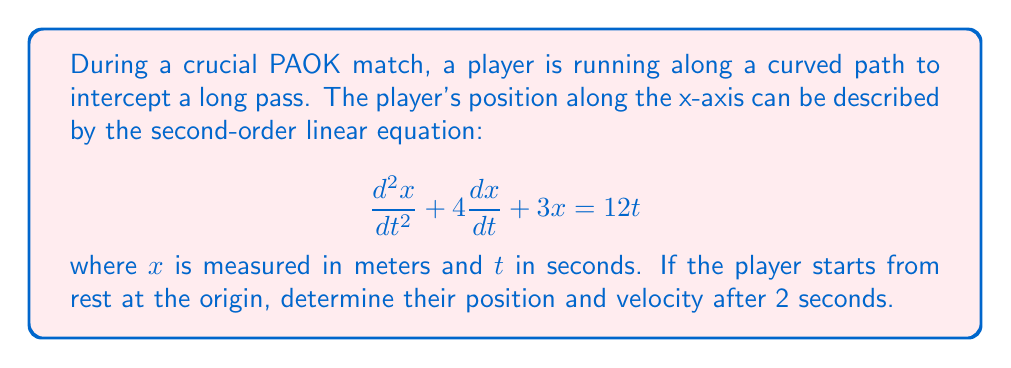Show me your answer to this math problem. To solve this problem, we need to find the general solution to the given second-order linear equation and then apply the initial conditions.

1) The general solution of the homogeneous equation $\frac{d^2x}{dt^2} + 4\frac{dx}{dt} + 3x = 0$ is:

   $x_h = c_1e^{-t} + c_2e^{-3t}$

2) A particular solution for the non-homogeneous equation is:

   $x_p = At + B$

   Substituting this into the original equation:
   $A + 4(A) + 3(At + B) = 12t$
   $A + 4A + 3At + 3B = 12t$
   
   Equating coefficients:
   $3A = 12$, so $A = 4$
   $5A + 3B = 0$, so $B = -\frac{20}{3}$

   Thus, $x_p = 4t - \frac{20}{3}$

3) The general solution is:

   $x = x_h + x_p = c_1e^{-t} + c_2e^{-3t} + 4t - \frac{20}{3}$

4) To find $c_1$ and $c_2$, we use the initial conditions:
   At $t = 0$: $x(0) = 0$ and $\frac{dx}{dt}(0) = 0$

   $0 = c_1 + c_2 - \frac{20}{3}$
   $0 = -c_1 - 3c_2 + 4$

   Solving this system:
   $c_1 = \frac{28}{3}$ and $c_2 = -\frac{8}{3}$

5) The final solution is:

   $x = \frac{28}{3}e^{-t} - \frac{8}{3}e^{-3t} + 4t - \frac{20}{3}$

6) The velocity is found by differentiating:

   $\frac{dx}{dt} = -\frac{28}{3}e^{-t} + 8e^{-3t} + 4$

7) At $t = 2$:

   $x(2) = \frac{28}{3}e^{-2} - \frac{8}{3}e^{-6} + 8 - \frac{20}{3}$
   $\frac{dx}{dt}(2) = -\frac{28}{3}e^{-2} + 8e^{-6} + 4$
Answer: Position at $t = 2$: $x(2) \approx 3.77$ meters
Velocity at $t = 2$: $\frac{dx}{dt}(2) \approx 5.22$ meters/second 